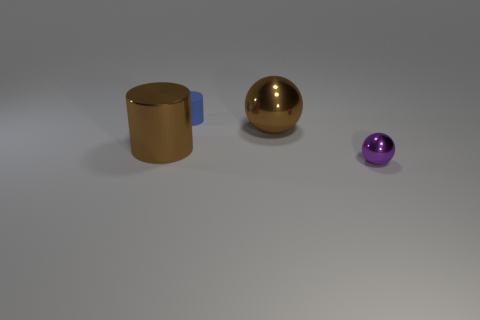Is there any other thing that has the same size as the purple metallic object?
Offer a terse response. Yes. What is the color of the ball behind the metallic object in front of the big cylinder?
Your answer should be very brief. Brown. The large brown metallic object that is to the left of the tiny thing that is left of the large brown metal thing to the right of the brown metal cylinder is what shape?
Make the answer very short. Cylinder. What is the size of the thing that is left of the large brown shiny sphere and behind the large brown cylinder?
Keep it short and to the point. Small. How many small balls have the same color as the matte cylinder?
Offer a terse response. 0. There is a object that is the same color as the big metal cylinder; what is it made of?
Your answer should be compact. Metal. What material is the small purple sphere?
Your response must be concise. Metal. Do the large brown thing on the right side of the blue rubber cylinder and the small purple object have the same material?
Your response must be concise. Yes. What is the shape of the brown thing that is on the right side of the big cylinder?
Give a very brief answer. Sphere. There is a brown object that is the same size as the metallic cylinder; what is its material?
Your answer should be compact. Metal. 